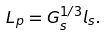Convert formula to latex. <formula><loc_0><loc_0><loc_500><loc_500>L _ { p } = G _ { s } ^ { 1 / 3 } l _ { s } .</formula> 